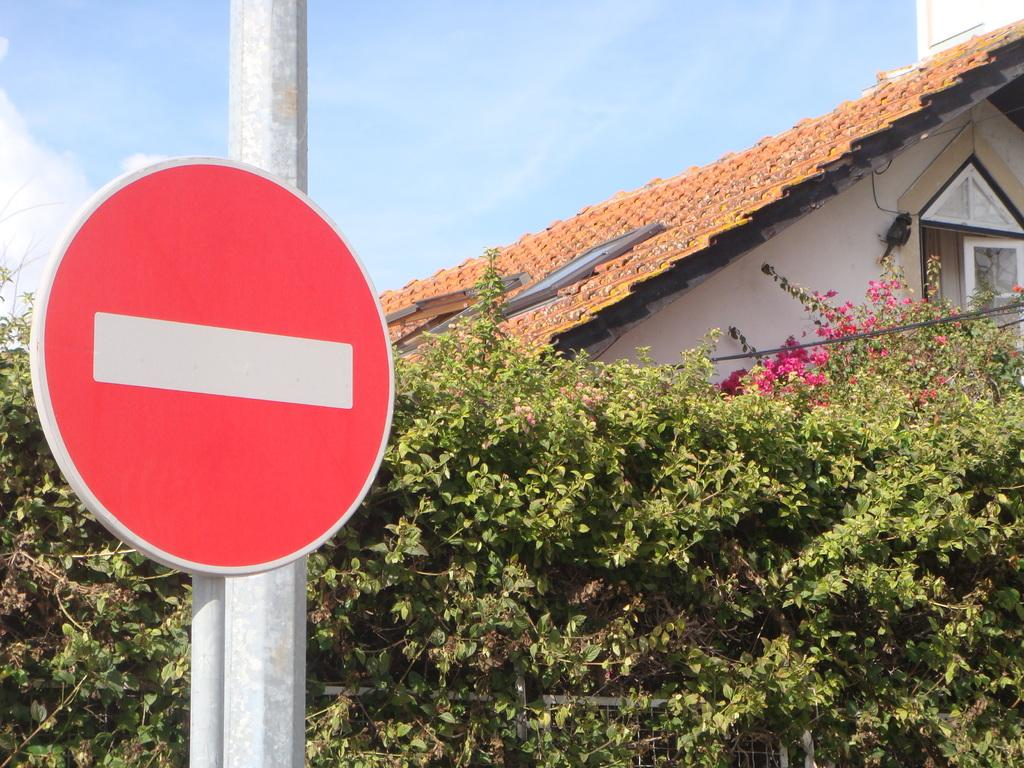What is on the pole that is visible in the image? There is a sign board on the pole in the image. What type of vegetation can be seen in the image? There are plants in the image. What type of barrier is present in the image? There is a fence in the image. What type of building is visible in the image? There is a house in the image. What is visible in the background of the image? The sky is visible in the background of the image. How many horses are grazing in the field in the image? There are no horses or fields present in the image. What type of lamp is hanging from the ceiling in the image? There is no lamp present in the image. 